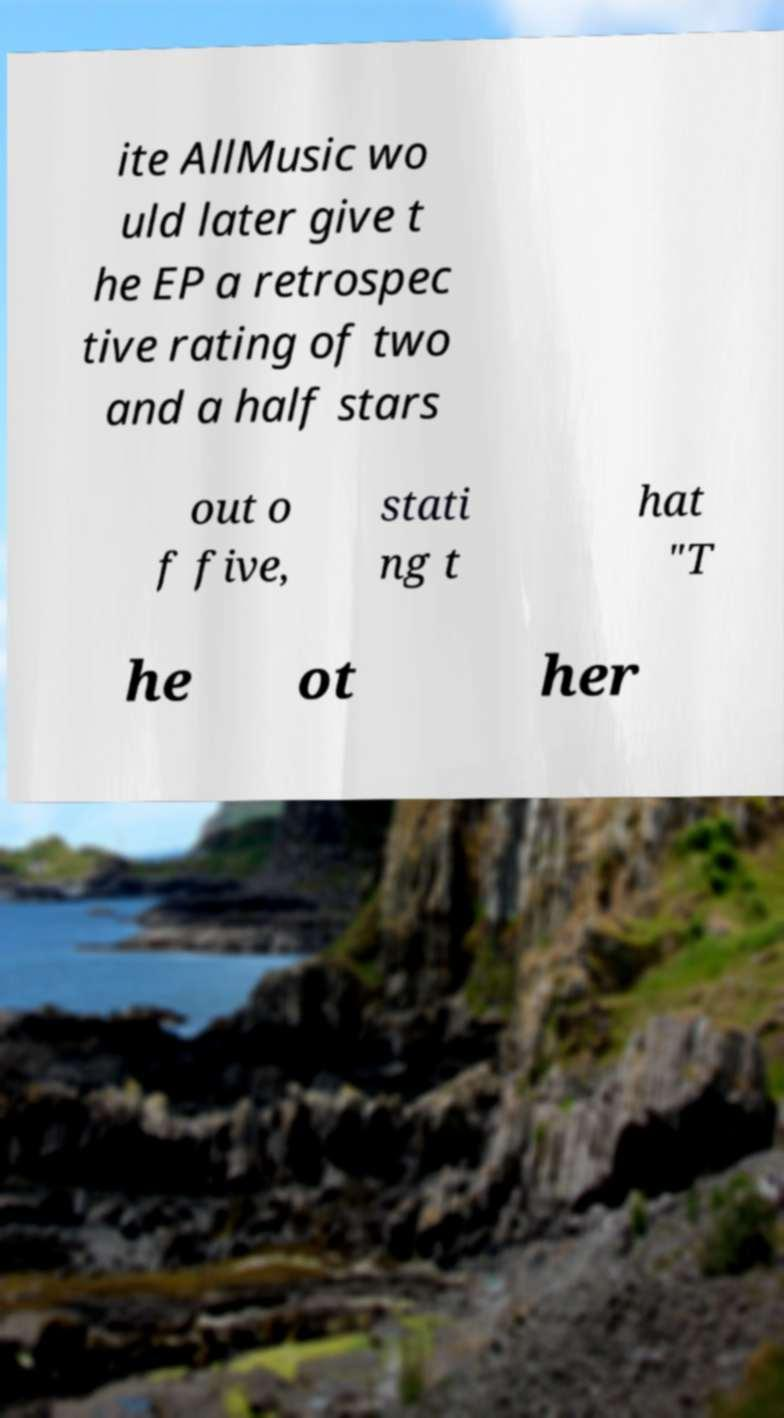For documentation purposes, I need the text within this image transcribed. Could you provide that? ite AllMusic wo uld later give t he EP a retrospec tive rating of two and a half stars out o f five, stati ng t hat "T he ot her 